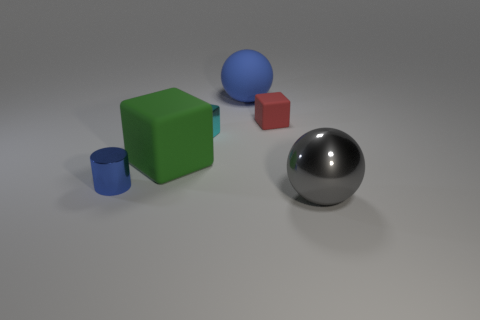Subtract all metallic cubes. How many cubes are left? 2 Subtract all red blocks. How many blocks are left? 2 Subtract all cylinders. How many objects are left? 5 Subtract 2 cubes. How many cubes are left? 1 Add 5 big green matte cubes. How many big green matte cubes are left? 6 Add 2 small cyan rubber cylinders. How many small cyan rubber cylinders exist? 2 Add 4 small red rubber cubes. How many objects exist? 10 Subtract 1 blue spheres. How many objects are left? 5 Subtract all green cylinders. Subtract all gray cubes. How many cylinders are left? 1 Subtract all blue cubes. How many brown spheres are left? 0 